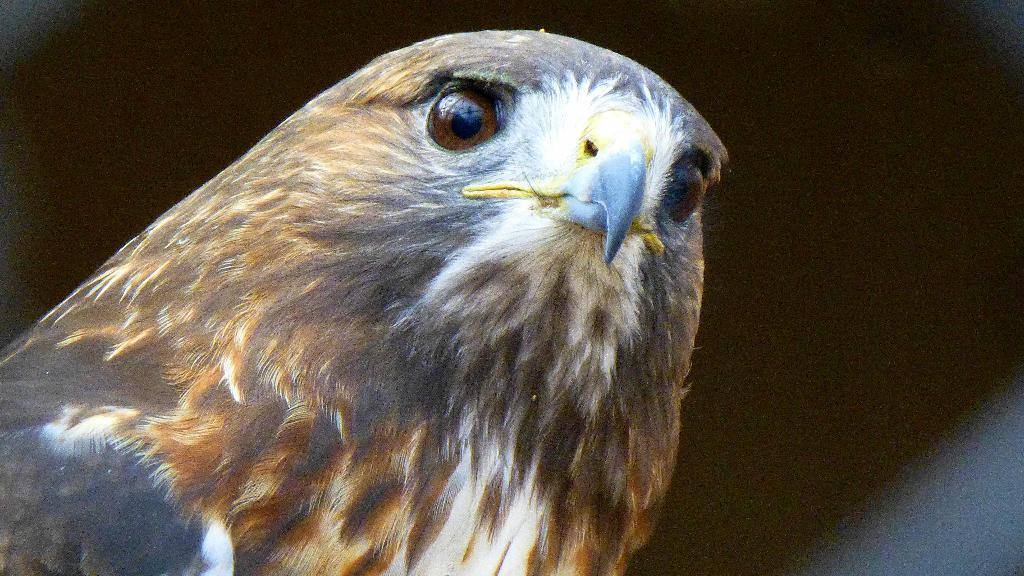What is the main subject of the image? There is a bird in the center of the image. Can you describe the bird's appearance? The bird has ash, brown, and white colors. What type of laborer can be seen working in the background of the image? There is no laborer present in the image; it only features a bird. How does the bird's appearance convey disgust in the image? The bird's appearance does not convey disgust, as there is no indication of emotion or context in the image. 